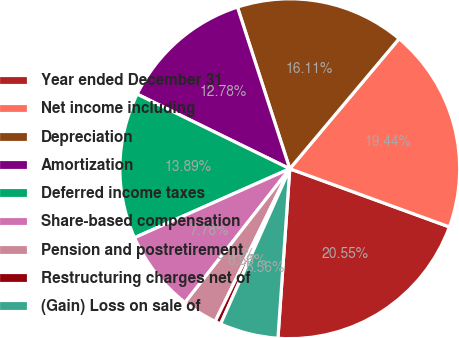<chart> <loc_0><loc_0><loc_500><loc_500><pie_chart><fcel>Year ended December 31<fcel>Net income including<fcel>Depreciation<fcel>Amortization<fcel>Deferred income taxes<fcel>Share-based compensation<fcel>Pension and postretirement<fcel>Restructuring charges net of<fcel>(Gain) Loss on sale of<nl><fcel>20.55%<fcel>19.44%<fcel>16.11%<fcel>12.78%<fcel>13.89%<fcel>7.78%<fcel>3.34%<fcel>0.56%<fcel>5.56%<nl></chart> 